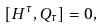<formula> <loc_0><loc_0><loc_500><loc_500>\left [ H ^ { \tau } , Q _ { \tau } \right ] = 0 ,</formula> 